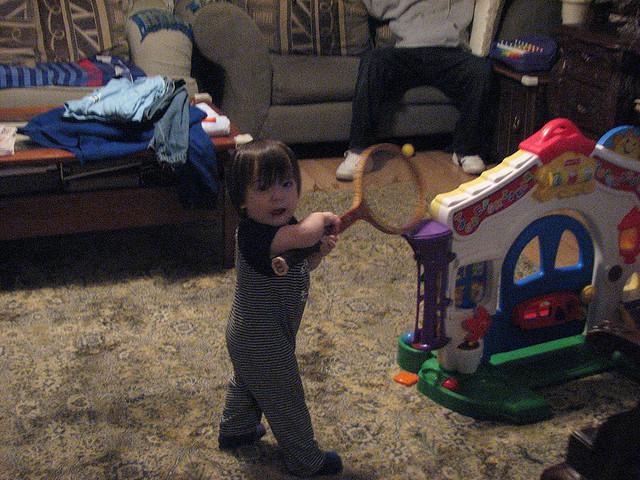Is this a public place?
Short answer required. No. What is the little boy holding?
Concise answer only. Tennis racket. Is this a professional tennis player?
Answer briefly. No. What is the kid doing?
Be succinct. Hitting ball. 